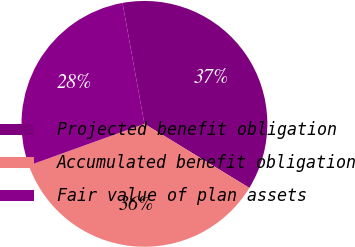Convert chart to OTSL. <chart><loc_0><loc_0><loc_500><loc_500><pie_chart><fcel>Projected benefit obligation<fcel>Accumulated benefit obligation<fcel>Fair value of plan assets<nl><fcel>36.58%<fcel>35.77%<fcel>27.65%<nl></chart> 